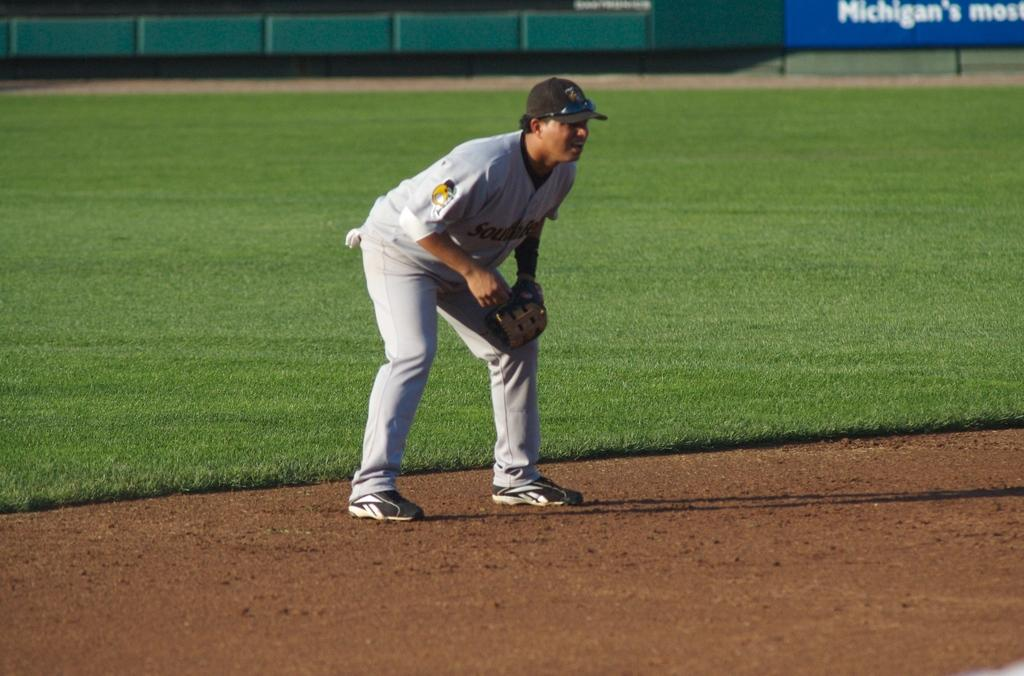<image>
Share a concise interpretation of the image provided. A baseball player stands on the field, with an advertisement for a Michigan business on the outfield wall. 